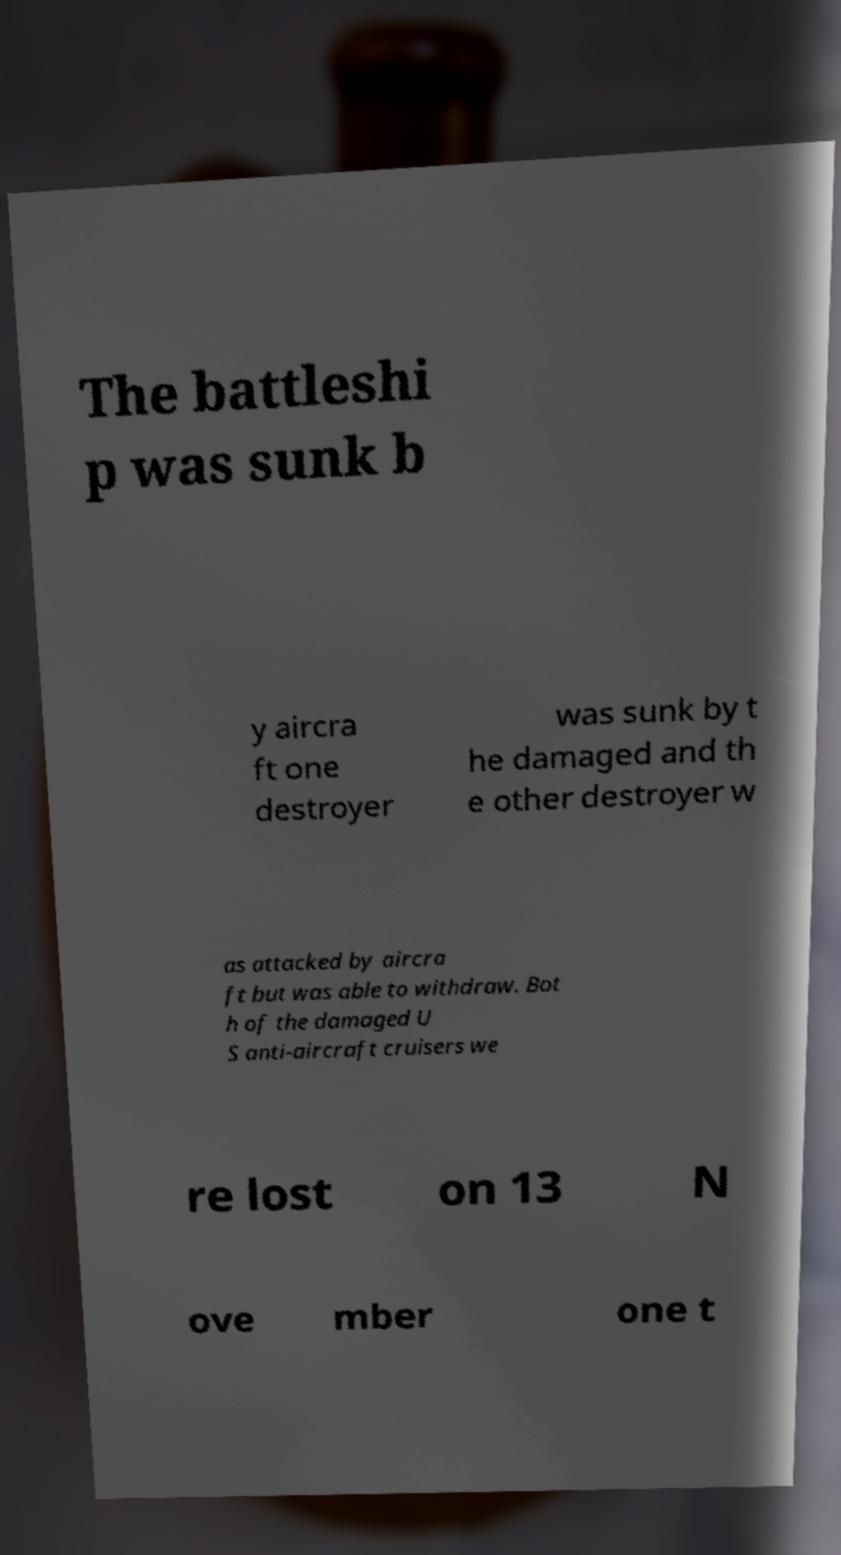For documentation purposes, I need the text within this image transcribed. Could you provide that? The battleshi p was sunk b y aircra ft one destroyer was sunk by t he damaged and th e other destroyer w as attacked by aircra ft but was able to withdraw. Bot h of the damaged U S anti-aircraft cruisers we re lost on 13 N ove mber one t 